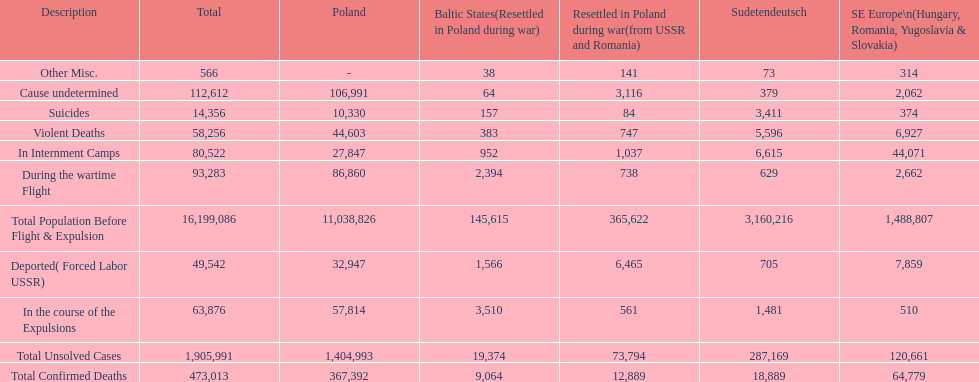What is the difference between suicides in poland and sudetendeutsch? 6919. 